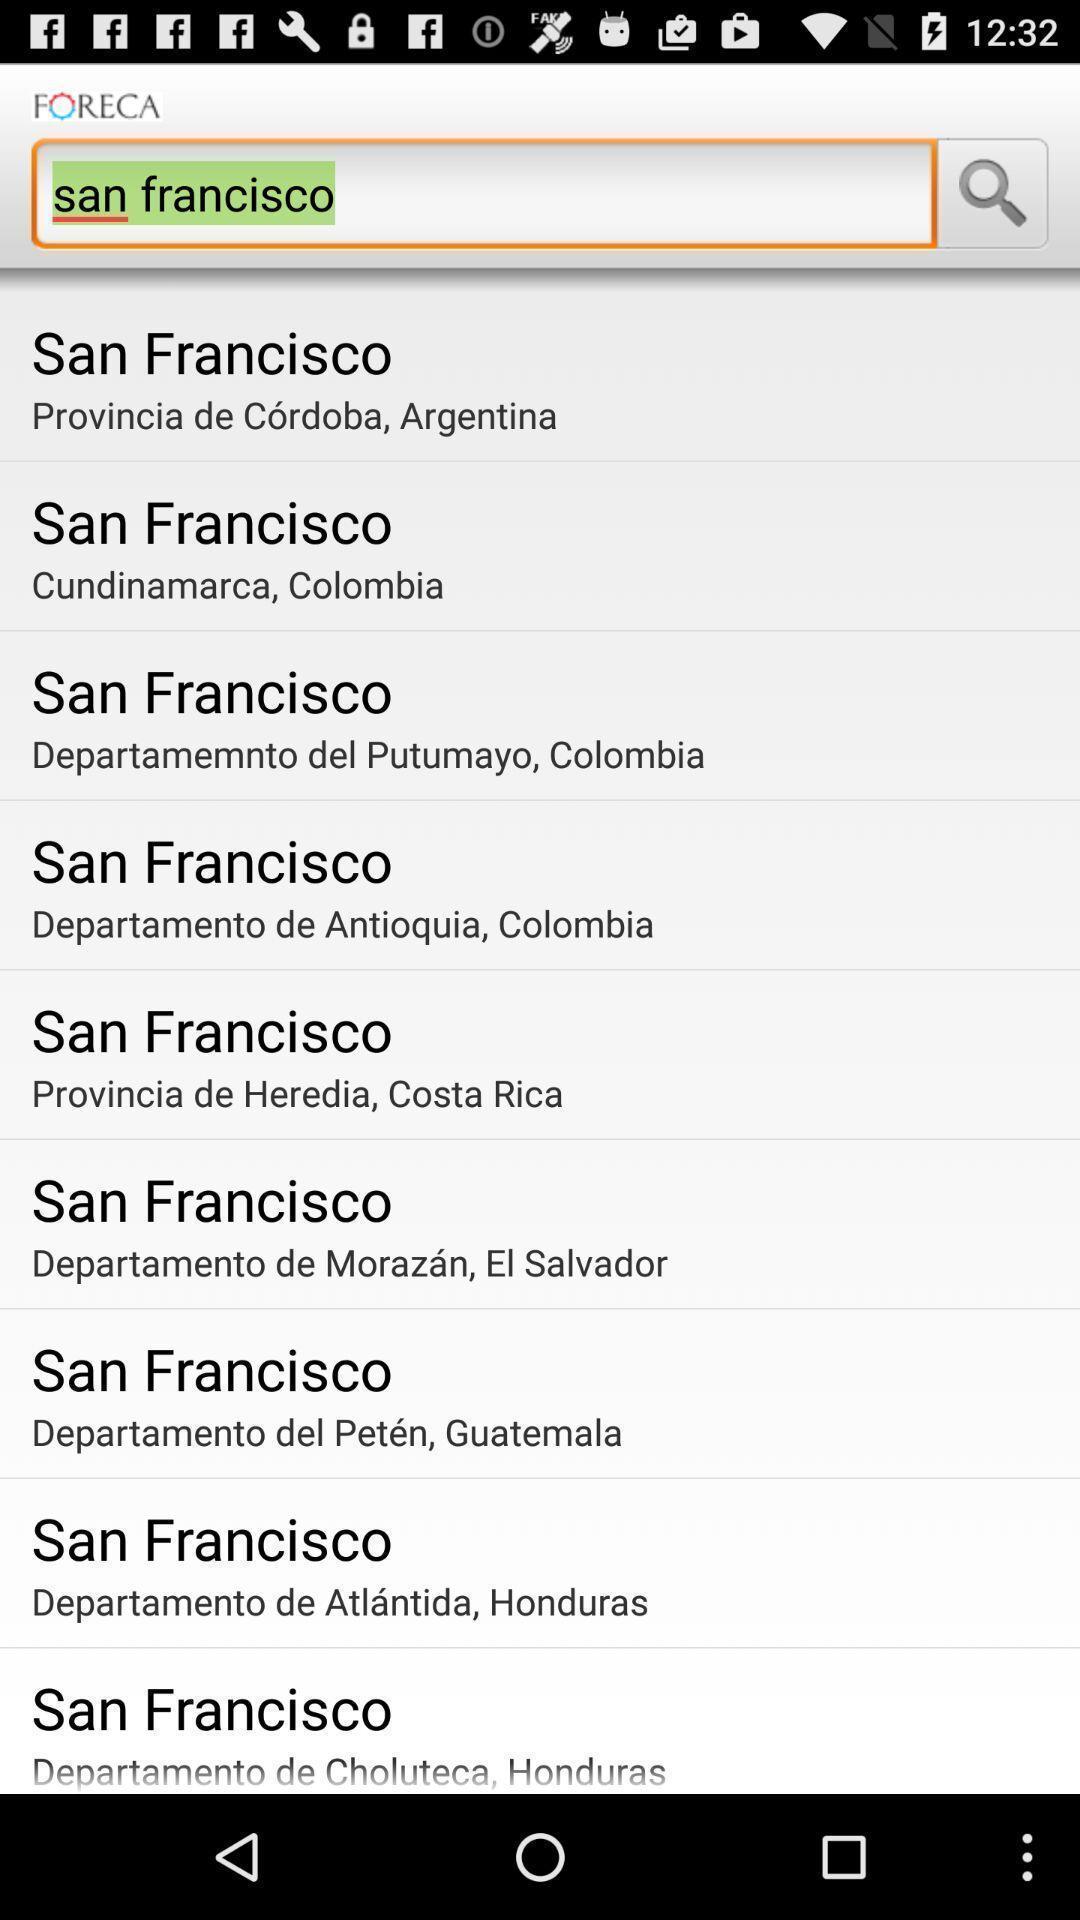Explain the elements present in this screenshot. Search option page of a weather app. 